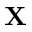<formula> <loc_0><loc_0><loc_500><loc_500>X</formula> 